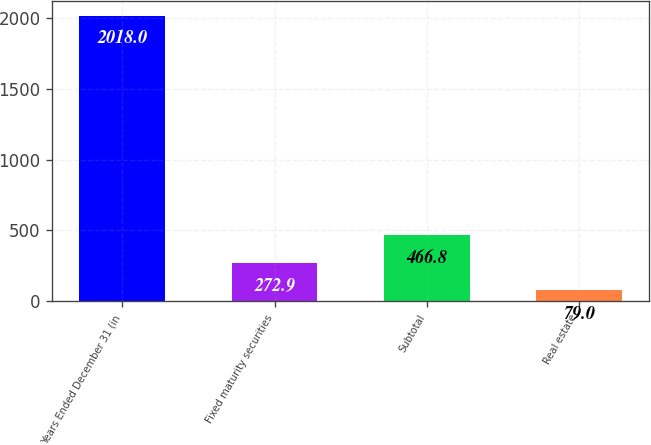<chart> <loc_0><loc_0><loc_500><loc_500><bar_chart><fcel>Years Ended December 31 (in<fcel>Fixed maturity securities<fcel>Subtotal<fcel>Real estate<nl><fcel>2018<fcel>272.9<fcel>466.8<fcel>79<nl></chart> 